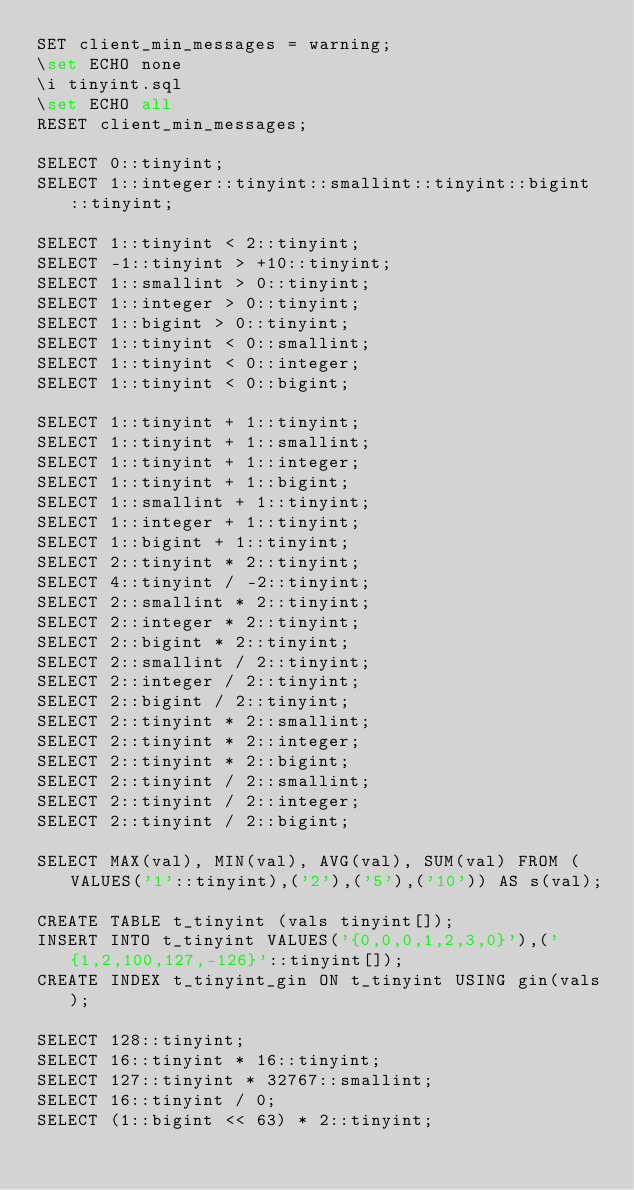<code> <loc_0><loc_0><loc_500><loc_500><_SQL_>SET client_min_messages = warning;
\set ECHO none
\i tinyint.sql
\set ECHO all
RESET client_min_messages;

SELECT 0::tinyint;
SELECT 1::integer::tinyint::smallint::tinyint::bigint::tinyint;

SELECT 1::tinyint < 2::tinyint;
SELECT -1::tinyint > +10::tinyint;
SELECT 1::smallint > 0::tinyint;
SELECT 1::integer > 0::tinyint;
SELECT 1::bigint > 0::tinyint;
SELECT 1::tinyint < 0::smallint;
SELECT 1::tinyint < 0::integer;
SELECT 1::tinyint < 0::bigint;

SELECT 1::tinyint + 1::tinyint;
SELECT 1::tinyint + 1::smallint;
SELECT 1::tinyint + 1::integer;
SELECT 1::tinyint + 1::bigint;
SELECT 1::smallint + 1::tinyint;
SELECT 1::integer + 1::tinyint;
SELECT 1::bigint + 1::tinyint;
SELECT 2::tinyint * 2::tinyint;
SELECT 4::tinyint / -2::tinyint;
SELECT 2::smallint * 2::tinyint;
SELECT 2::integer * 2::tinyint;
SELECT 2::bigint * 2::tinyint;
SELECT 2::smallint / 2::tinyint;
SELECT 2::integer / 2::tinyint;
SELECT 2::bigint / 2::tinyint;
SELECT 2::tinyint * 2::smallint;
SELECT 2::tinyint * 2::integer;
SELECT 2::tinyint * 2::bigint;
SELECT 2::tinyint / 2::smallint;
SELECT 2::tinyint / 2::integer;
SELECT 2::tinyint / 2::bigint;

SELECT MAX(val), MIN(val), AVG(val), SUM(val) FROM (VALUES('1'::tinyint),('2'),('5'),('10')) AS s(val);

CREATE TABLE t_tinyint (vals tinyint[]);
INSERT INTO t_tinyint VALUES('{0,0,0,1,2,3,0}'),('{1,2,100,127,-126}'::tinyint[]);
CREATE INDEX t_tinyint_gin ON t_tinyint USING gin(vals);

SELECT 128::tinyint;
SELECT 16::tinyint * 16::tinyint;
SELECT 127::tinyint * 32767::smallint;
SELECT 16::tinyint / 0;
SELECT (1::bigint << 63) * 2::tinyint;
</code> 